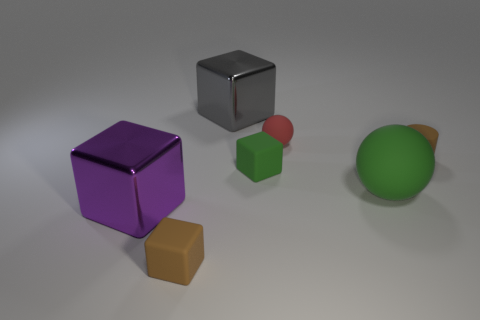Subtract 1 blocks. How many blocks are left? 3 Subtract all green blocks. How many blocks are left? 3 Add 1 large cyan rubber objects. How many objects exist? 8 Subtract all green cubes. How many cubes are left? 3 Subtract all cylinders. How many objects are left? 6 Subtract all green blocks. Subtract all brown spheres. How many blocks are left? 3 Subtract 0 yellow cubes. How many objects are left? 7 Subtract all balls. Subtract all tiny red matte things. How many objects are left? 4 Add 7 red matte balls. How many red matte balls are left? 8 Add 5 rubber cylinders. How many rubber cylinders exist? 6 